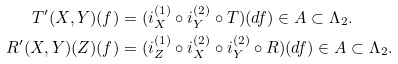<formula> <loc_0><loc_0><loc_500><loc_500>T ^ { \prime } ( X , Y ) ( f ) & = ( i _ { X } ^ { ( 1 ) } \circ i _ { Y } ^ { ( 2 ) } \circ T ) ( d f ) \in A \subset \Lambda _ { 2 } . \\ R ^ { \prime } ( X , Y ) ( Z ) ( f ) & = ( i _ { Z } ^ { ( 1 ) } \circ i _ { X } ^ { ( 2 ) } \circ i _ { Y } ^ { ( 2 ) } \circ R ) ( d f ) \in A \subset \Lambda _ { 2 } .</formula> 